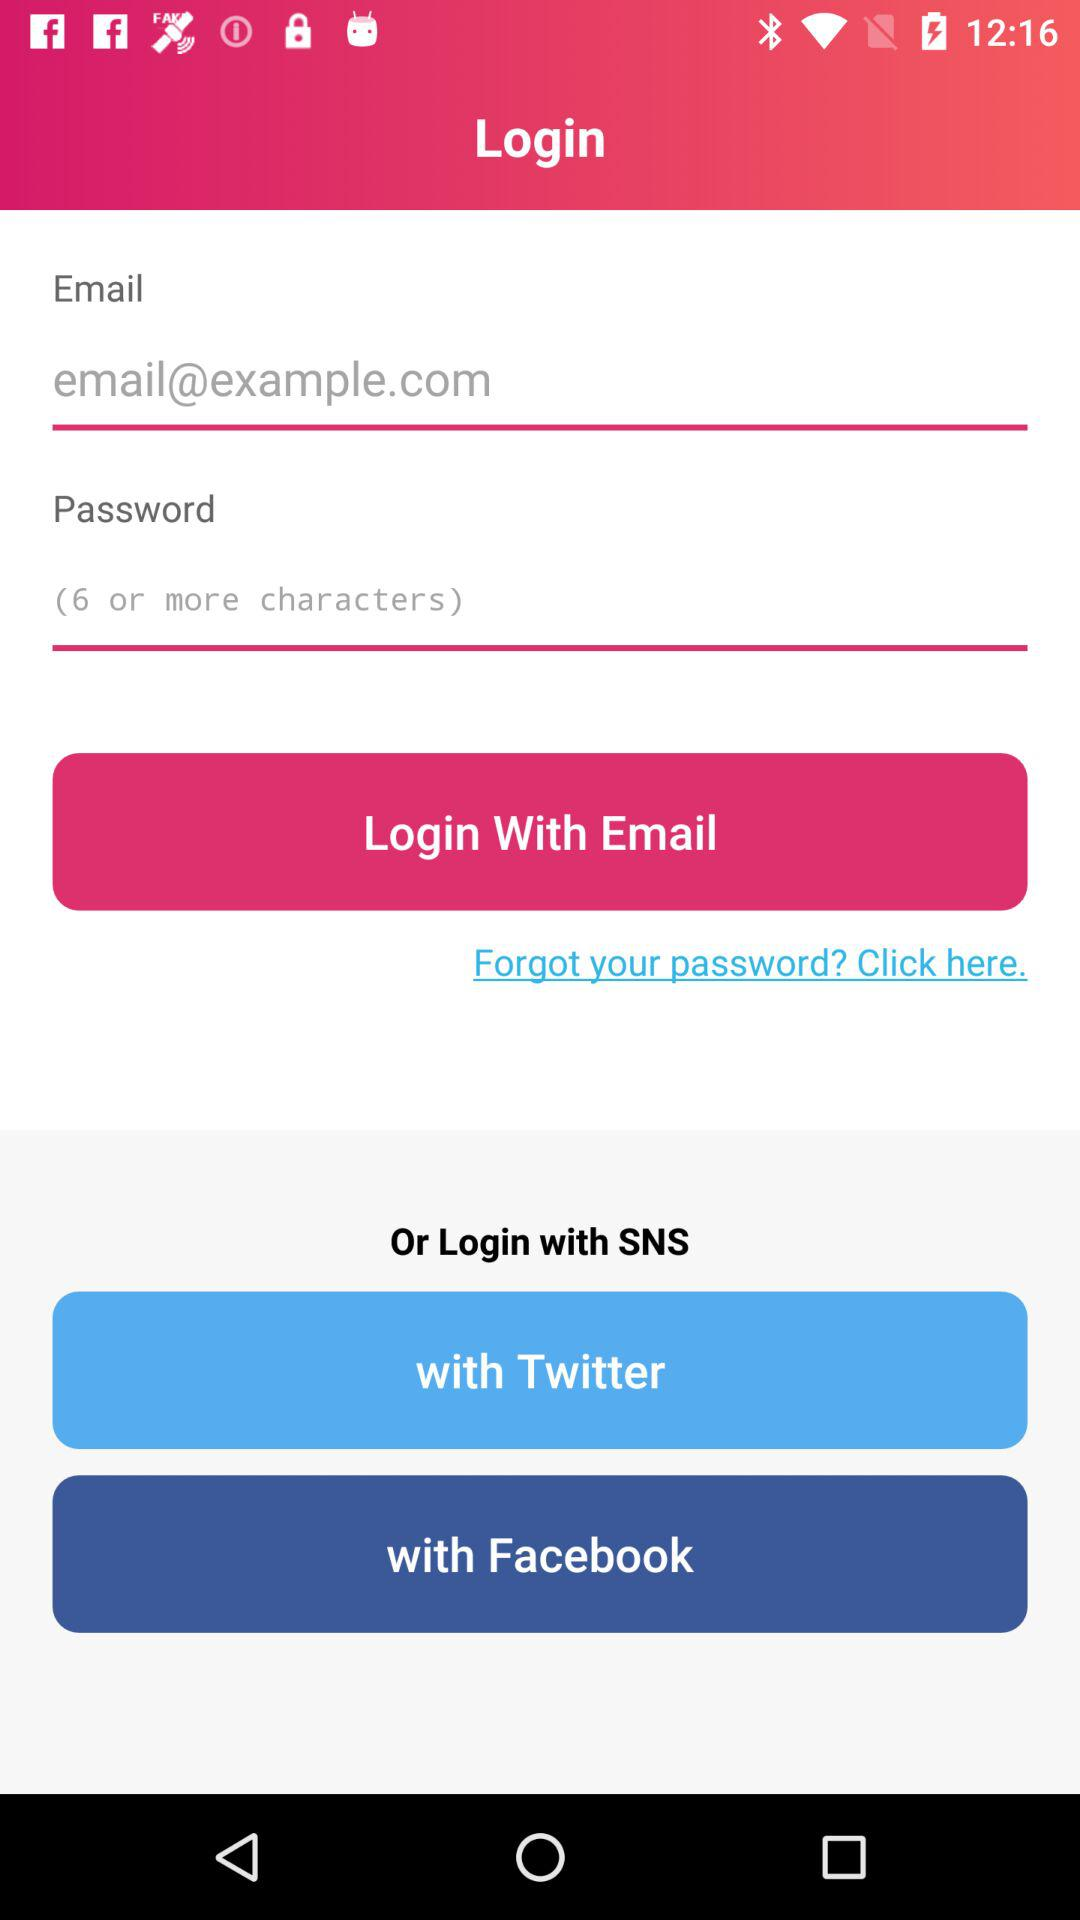What are the login options? The login options are "SNS", "Twitter" and "Facebook". 